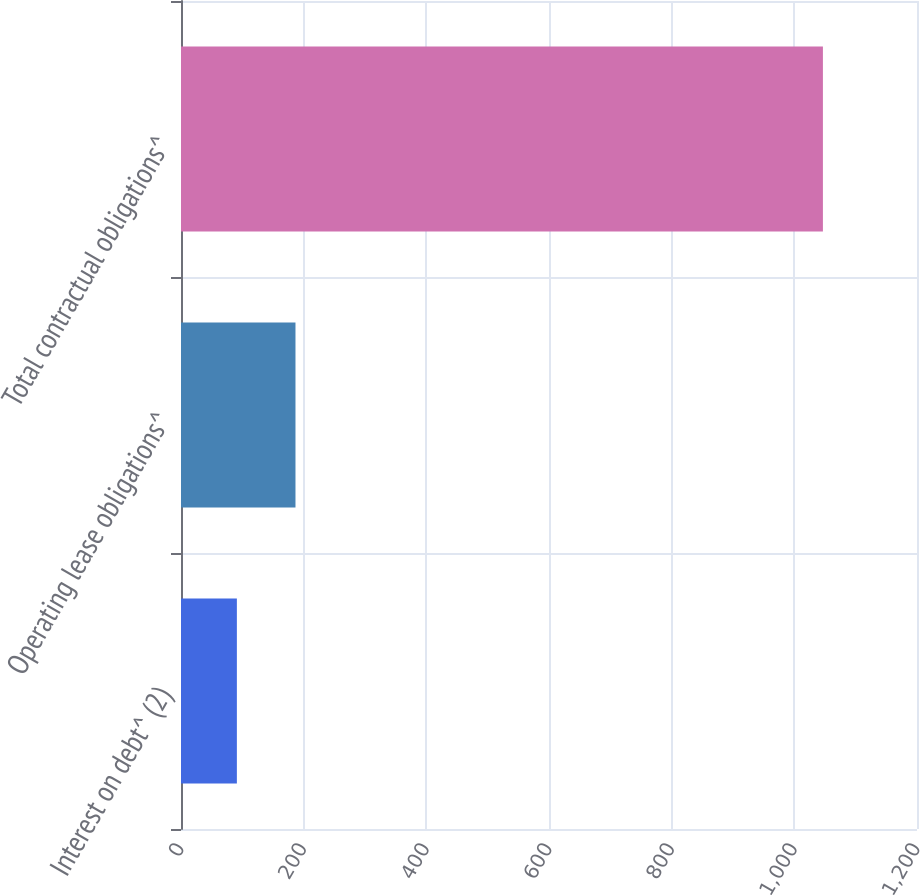Convert chart to OTSL. <chart><loc_0><loc_0><loc_500><loc_500><bar_chart><fcel>Interest on debt^ (2)<fcel>Operating lease obligations^<fcel>Total contractual obligations^<nl><fcel>91.1<fcel>186.65<fcel>1046.6<nl></chart> 